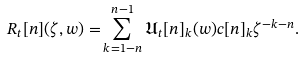Convert formula to latex. <formula><loc_0><loc_0><loc_500><loc_500>R _ { t } [ n ] ( \zeta , w ) = & \sum _ { k = 1 - n } ^ { n - 1 } \mathfrak { U } _ { t } [ n ] _ { k } ( w ) c [ n ] _ { k } \zeta ^ { - k - n } .</formula> 